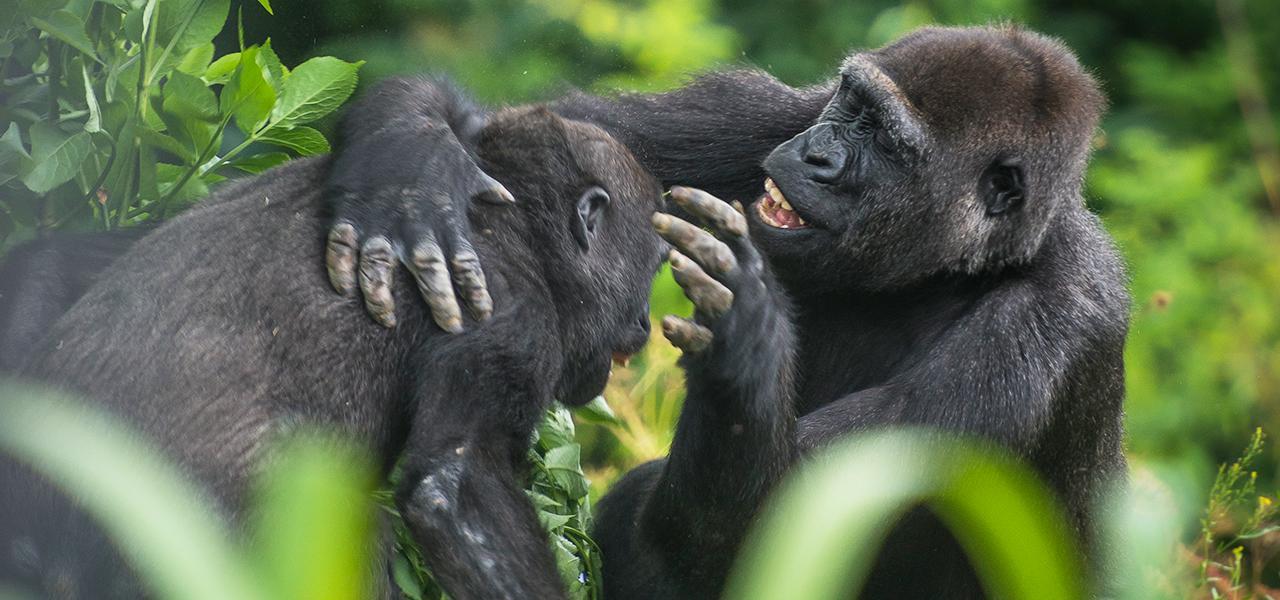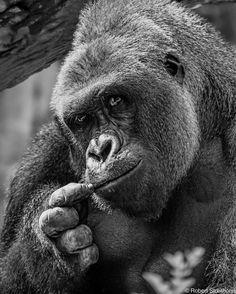The first image is the image on the left, the second image is the image on the right. Considering the images on both sides, is "One gorilla is scratching its own chin." valid? Answer yes or no. Yes. 